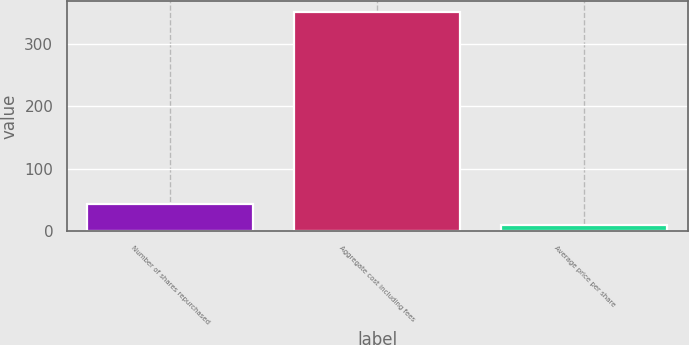Convert chart. <chart><loc_0><loc_0><loc_500><loc_500><bar_chart><fcel>Number of shares repurchased<fcel>Aggregate cost including fees<fcel>Average price per share<nl><fcel>44.7<fcel>350.5<fcel>10.72<nl></chart> 